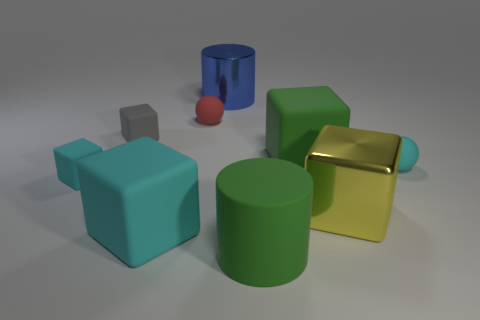The blue thing that is behind the tiny cyan object to the left of the large cylinder that is left of the big rubber cylinder is made of what material?
Provide a short and direct response. Metal. Is the size of the blue cylinder the same as the cyan cube to the right of the small gray block?
Offer a very short reply. Yes. What material is the big cyan thing that is the same shape as the yellow metallic object?
Your answer should be very brief. Rubber. There is a cylinder that is on the right side of the large metallic object that is to the left of the large rubber object in front of the large cyan rubber cube; what size is it?
Keep it short and to the point. Large. Do the shiny cylinder and the red object have the same size?
Make the answer very short. No. What material is the tiny sphere that is to the left of the metallic block that is to the right of the small gray rubber object made of?
Your answer should be very brief. Rubber. Does the green rubber thing in front of the tiny cyan cube have the same shape as the blue thing that is behind the large cyan matte thing?
Give a very brief answer. Yes. Is the number of large green cylinders on the left side of the gray rubber block the same as the number of large gray metallic blocks?
Give a very brief answer. Yes. Is there a large rubber cube behind the big thing to the left of the big blue metallic cylinder?
Make the answer very short. Yes. Is there any other thing that has the same color as the metal cylinder?
Your response must be concise. No. 